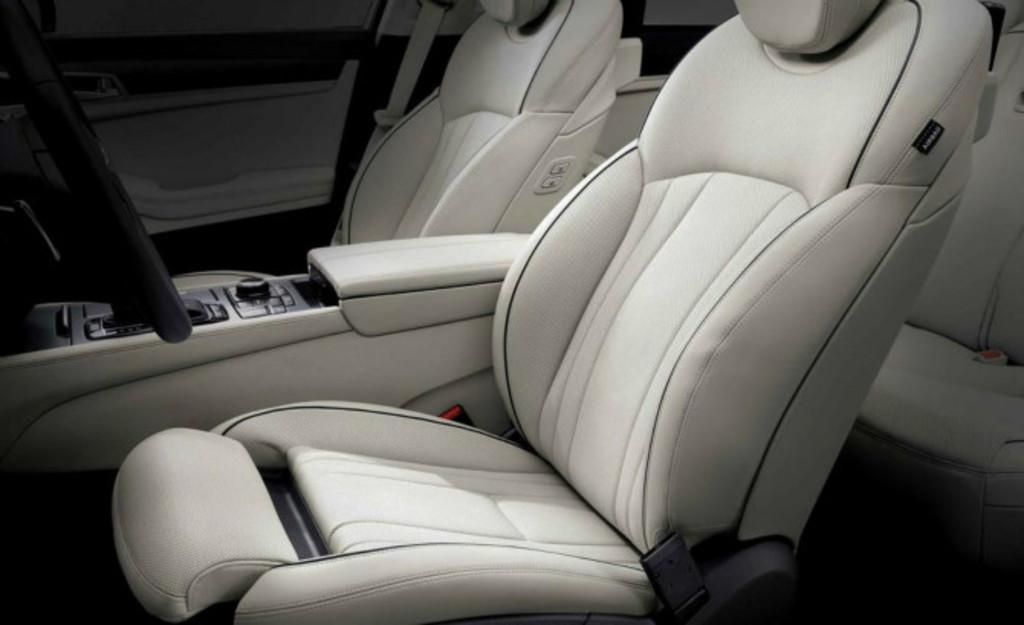What type of setting is depicted in the image? The image is an inside view of a vehicle. Where is the steering wheel located in the image? The steering wheel is on the left side of the image. What can be found in the middle of the image? There are seats in the middle of the image. Can you see any frogs in the garden through the window in the image? There is no window or garden visible in the image, and therefore no frogs can be seen. 